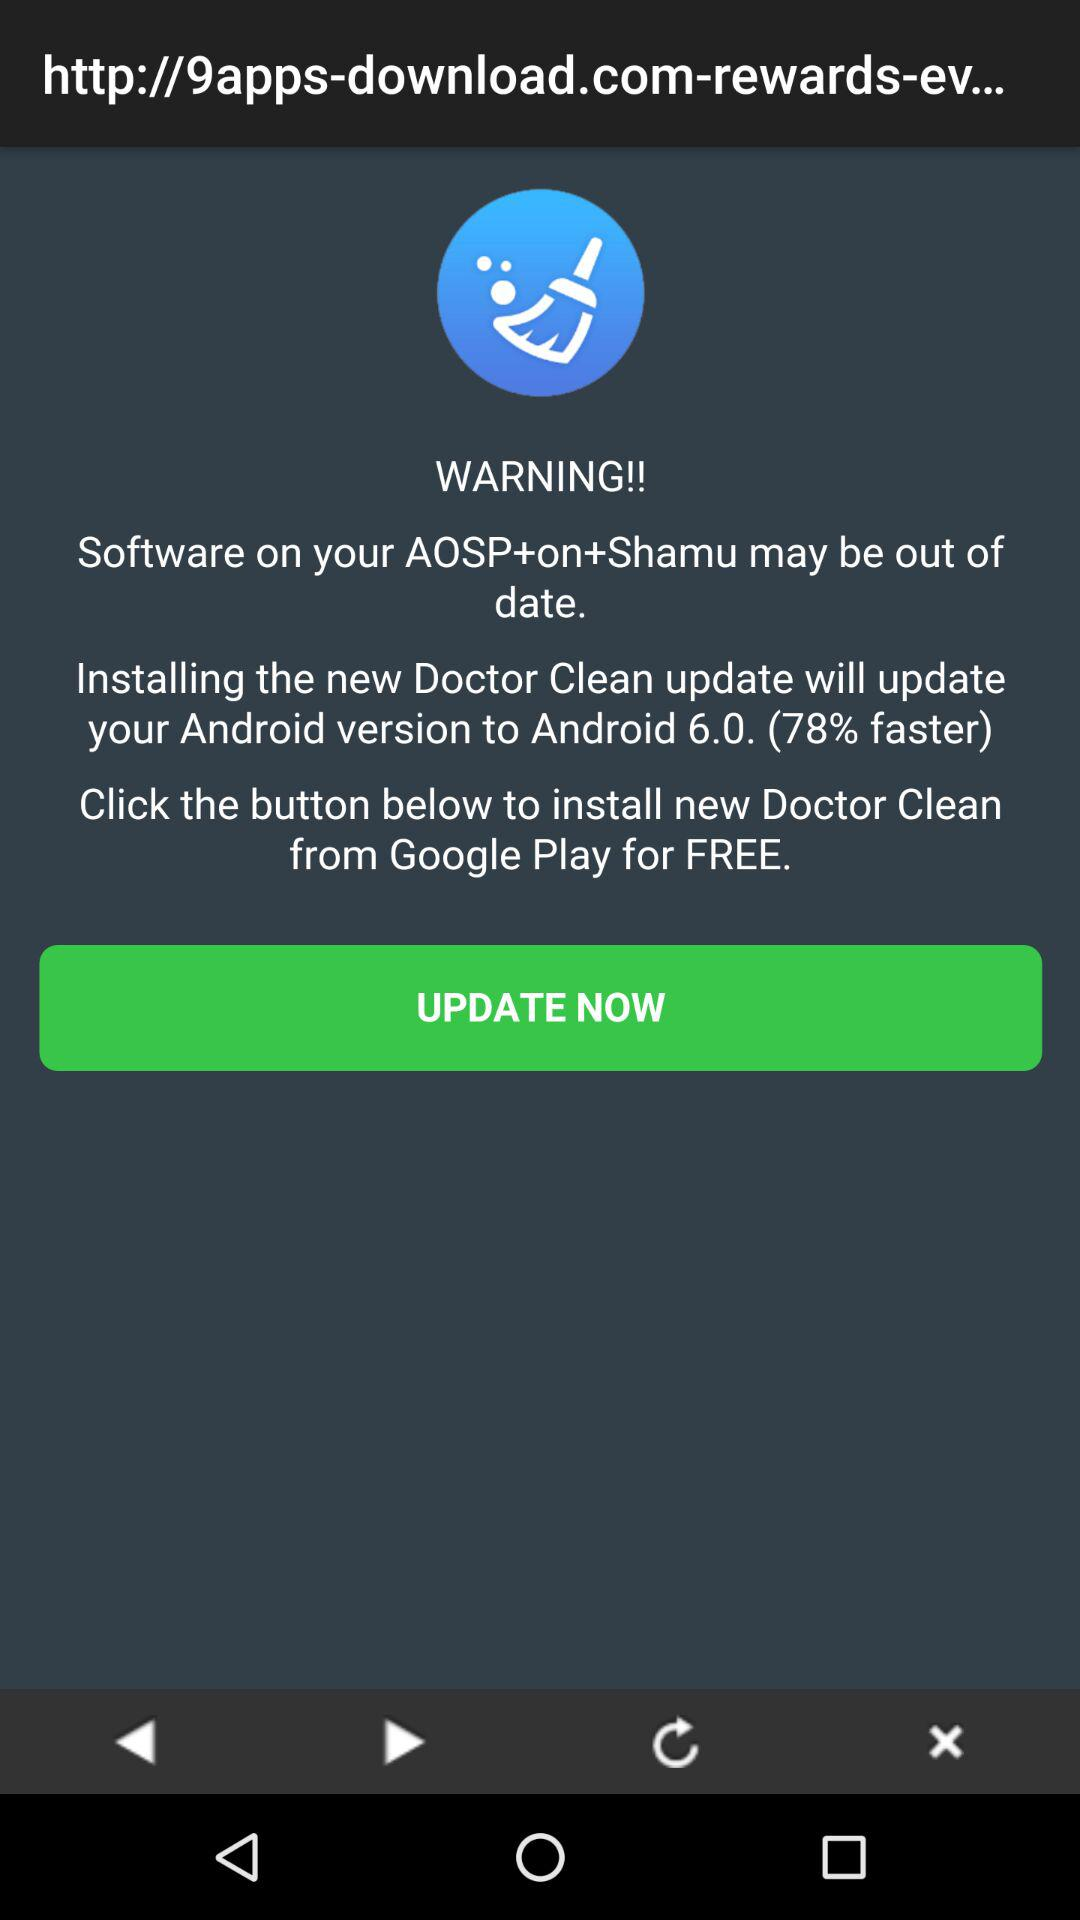What is the new version? The new version is Android 6.0. 